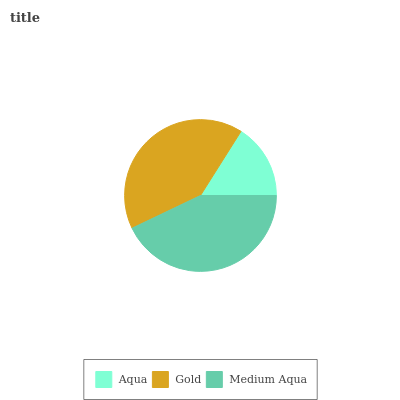Is Aqua the minimum?
Answer yes or no. Yes. Is Medium Aqua the maximum?
Answer yes or no. Yes. Is Gold the minimum?
Answer yes or no. No. Is Gold the maximum?
Answer yes or no. No. Is Gold greater than Aqua?
Answer yes or no. Yes. Is Aqua less than Gold?
Answer yes or no. Yes. Is Aqua greater than Gold?
Answer yes or no. No. Is Gold less than Aqua?
Answer yes or no. No. Is Gold the high median?
Answer yes or no. Yes. Is Gold the low median?
Answer yes or no. Yes. Is Aqua the high median?
Answer yes or no. No. Is Aqua the low median?
Answer yes or no. No. 